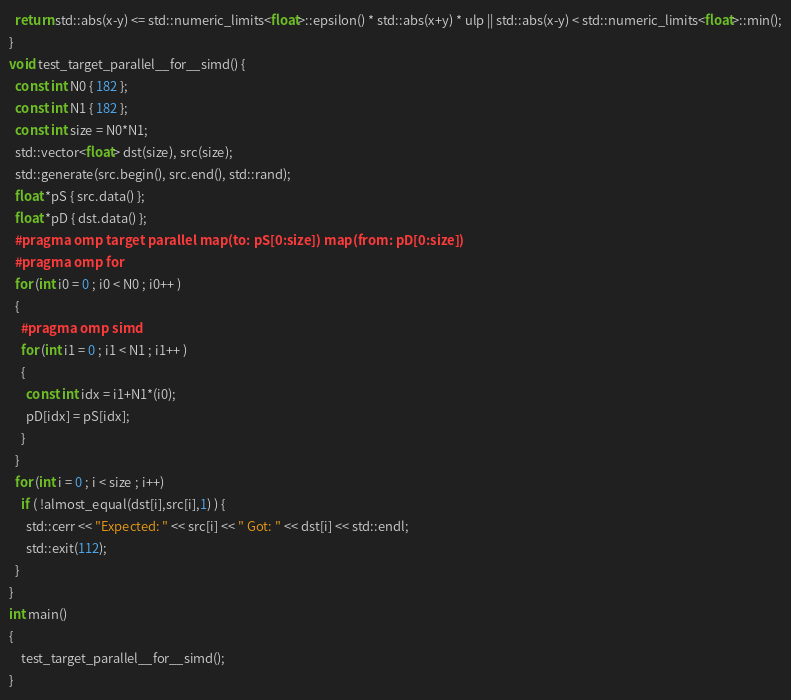<code> <loc_0><loc_0><loc_500><loc_500><_C++_>  return std::abs(x-y) <= std::numeric_limits<float>::epsilon() * std::abs(x+y) * ulp || std::abs(x-y) < std::numeric_limits<float>::min();
}
void test_target_parallel__for__simd() {
  const int N0 { 182 };
  const int N1 { 182 };
  const int size = N0*N1;
  std::vector<float> dst(size), src(size);
  std::generate(src.begin(), src.end(), std::rand);
  float *pS { src.data() };
  float *pD { dst.data() };
  #pragma omp target parallel map(to: pS[0:size]) map(from: pD[0:size])
  #pragma omp for
  for (int i0 = 0 ; i0 < N0 ; i0++ )
  {
    #pragma omp simd
    for (int i1 = 0 ; i1 < N1 ; i1++ )
    {
      const int idx = i1+N1*(i0);
      pD[idx] = pS[idx];
    }
  }
  for (int i = 0 ; i < size ; i++)
    if ( !almost_equal(dst[i],src[i],1) ) {
      std::cerr << "Expected: " << src[i] << " Got: " << dst[i] << std::endl;
      std::exit(112);
  }
}
int main()
{
    test_target_parallel__for__simd();
}
</code> 